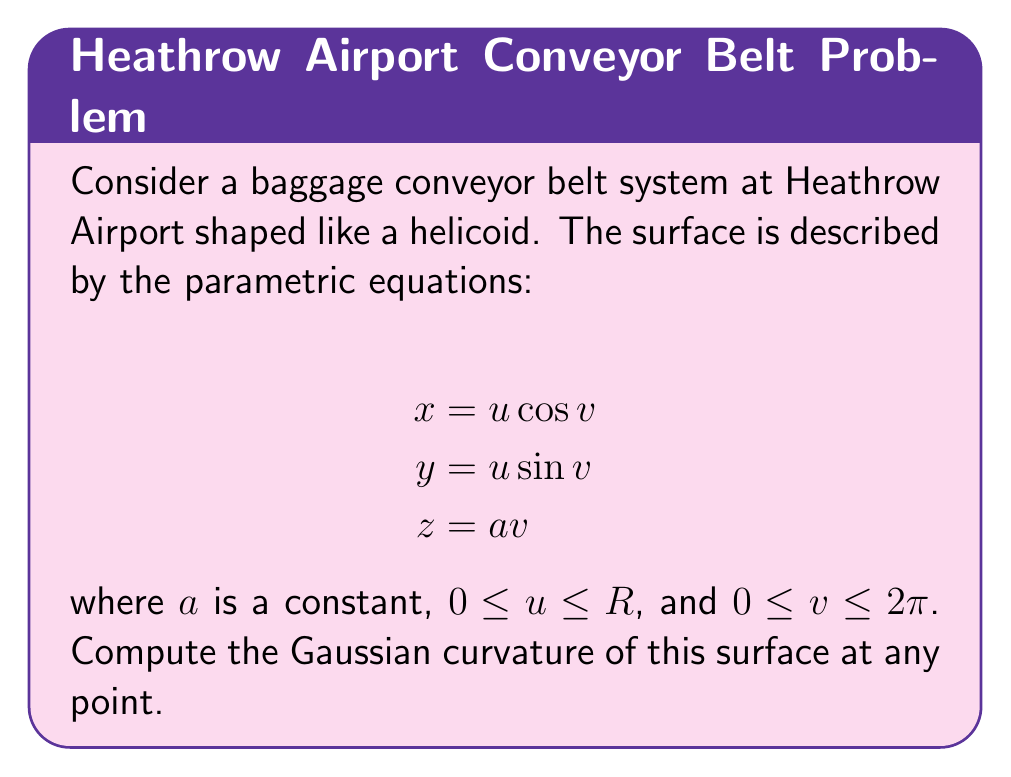Can you answer this question? To compute the Gaussian curvature, we'll follow these steps:

1) First, we need to find the fundamental forms. Let's calculate the partial derivatives:

   $$\mathbf{r}_u = (\cos v, \sin v, 0)$$
   $$\mathbf{r}_v = (-u \sin v, u \cos v, a)$$

2) Now we can calculate the coefficients of the first fundamental form:

   $$E = \mathbf{r}_u \cdot \mathbf{r}_u = \cos^2 v + \sin^2 v = 1$$
   $$F = \mathbf{r}_u \cdot \mathbf{r}_v = 0$$
   $$G = \mathbf{r}_v \cdot \mathbf{r}_v = u^2 \sin^2 v + u^2 \cos^2 v + a^2 = u^2 + a^2$$

3) Next, we need the second partial derivatives:

   $$\mathbf{r}_{uu} = (0, 0, 0)$$
   $$\mathbf{r}_{uv} = (-\sin v, \cos v, 0)$$
   $$\mathbf{r}_{vv} = (-u \cos v, -u \sin v, 0)$$

4) Now we can calculate the coefficients of the second fundamental form. We need the unit normal vector:

   $$\mathbf{N} = \frac{\mathbf{r}_u \times \mathbf{r}_v}{|\mathbf{r}_u \times \mathbf{r}_v|} = \frac{(a \sin v, -a \cos v, u)}{\sqrt{a^2 + u^2}}$$

5) The coefficients of the second fundamental form are:

   $$L = \mathbf{r}_{uu} \cdot \mathbf{N} = 0$$
   $$M = \mathbf{r}_{uv} \cdot \mathbf{N} = \frac{-a}{\sqrt{a^2 + u^2}}$$
   $$N = \mathbf{r}_{vv} \cdot \mathbf{N} = \frac{-u^2}{\sqrt{a^2 + u^2}}$$

6) The Gaussian curvature K is given by:

   $$K = \frac{LN - M^2}{EG - F^2}$$

7) Substituting the values we found:

   $$K = \frac{0 \cdot \frac{-u^2}{\sqrt{a^2 + u^2}} - (\frac{-a}{\sqrt{a^2 + u^2}})^2}{1 \cdot (u^2 + a^2) - 0^2}$$

8) Simplifying:

   $$K = \frac{-a^2}{(a^2 + u^2)^2}$$

This is the Gaussian curvature at any point on the helicoid-shaped conveyor belt.
Answer: $$K = \frac{-a^2}{(a^2 + u^2)^2}$$ 